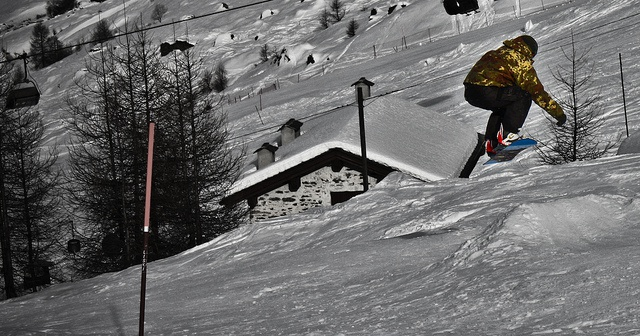Describe the objects in this image and their specific colors. I can see people in black, maroon, darkgray, and olive tones and snowboard in black, darkblue, and gray tones in this image. 